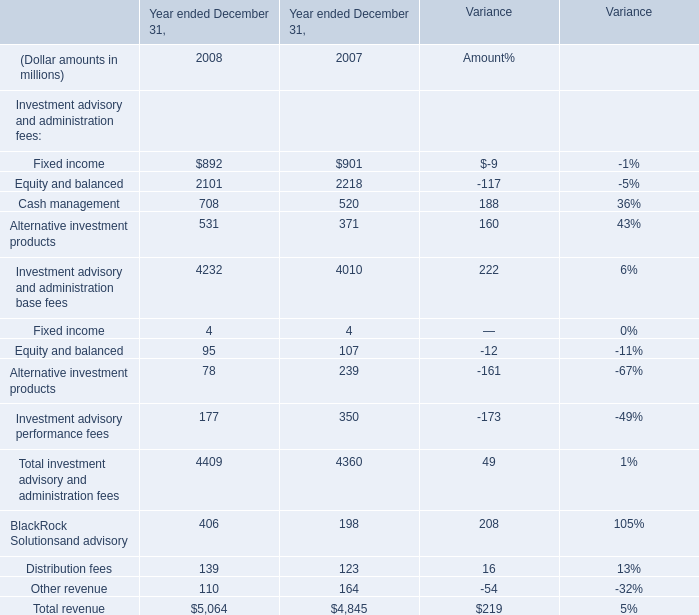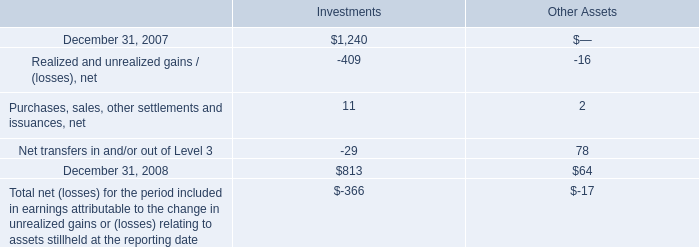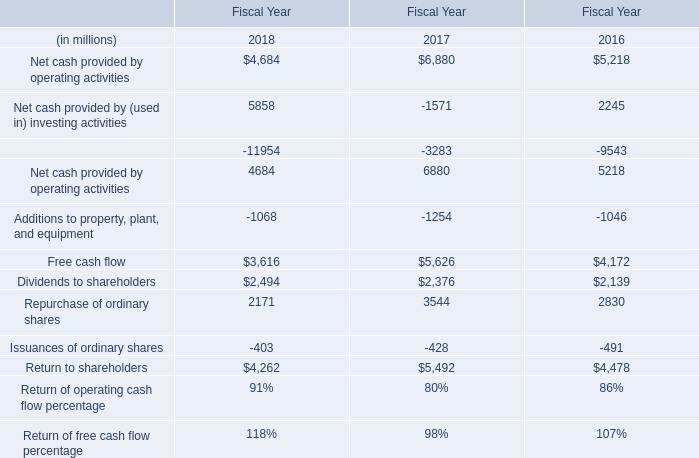What's the sum of Equity and balanced of Year ended December 31, 2007, and Additions to property, plant, and equipment of Fiscal Year 2017 ? 
Computations: (2218.0 + 1254.0)
Answer: 3472.0. for 2017 , what was the total net losses for the period ? ( $ ) 
Computations: (366 + 17)
Answer: 383.0. 